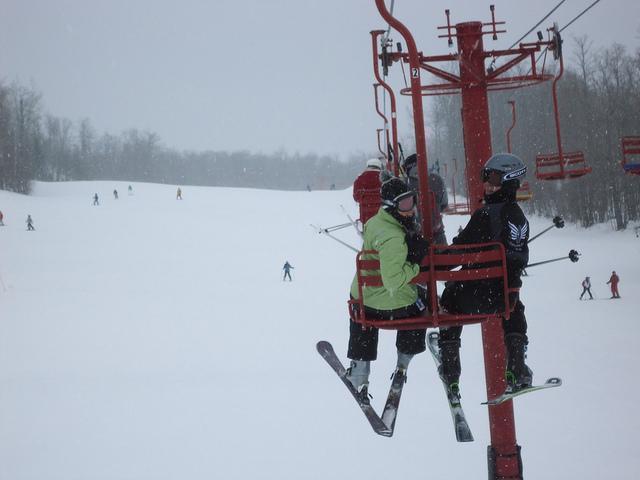Why are they so high up?
Indicate the correct response and explain using: 'Answer: answer
Rationale: rationale.'
Options: Broken mechanism, carrying uphill, lost, daredevils. Answer: carrying uphill.
Rationale: Based on their equipment and setting, the people are skiing and sitting on a chairlift which is known to bring people to the top of the mountain. 